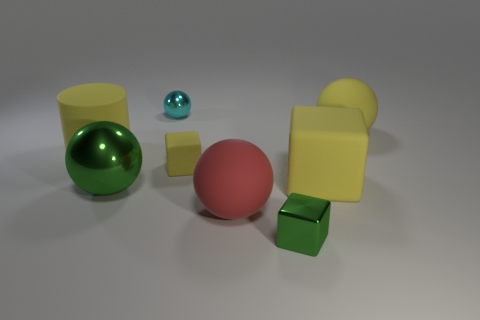The tiny metal thing that is behind the yellow matte ball has what shape?
Your answer should be compact. Sphere. What number of objects are yellow balls or green spheres that are behind the big red rubber object?
Offer a very short reply. 2. Do the green ball and the tiny green object have the same material?
Your answer should be very brief. Yes. Is the number of metallic objects that are behind the small cyan metal ball the same as the number of big objects that are on the left side of the big metallic ball?
Provide a succinct answer. No. There is a large shiny ball; what number of red rubber balls are left of it?
Your response must be concise. 0. What number of things are either gray blocks or tiny matte objects?
Provide a short and direct response. 1. What number of yellow objects have the same size as the cyan object?
Your answer should be very brief. 1. What shape is the big matte thing left of the large rubber sphere that is in front of the big rubber cube?
Provide a short and direct response. Cylinder. Are there fewer small cyan things than big yellow rubber things?
Your answer should be compact. Yes. What color is the shiny ball that is behind the large green metallic object?
Your answer should be very brief. Cyan. 